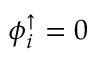<formula> <loc_0><loc_0><loc_500><loc_500>\phi _ { i } ^ { \uparrow } = 0</formula> 